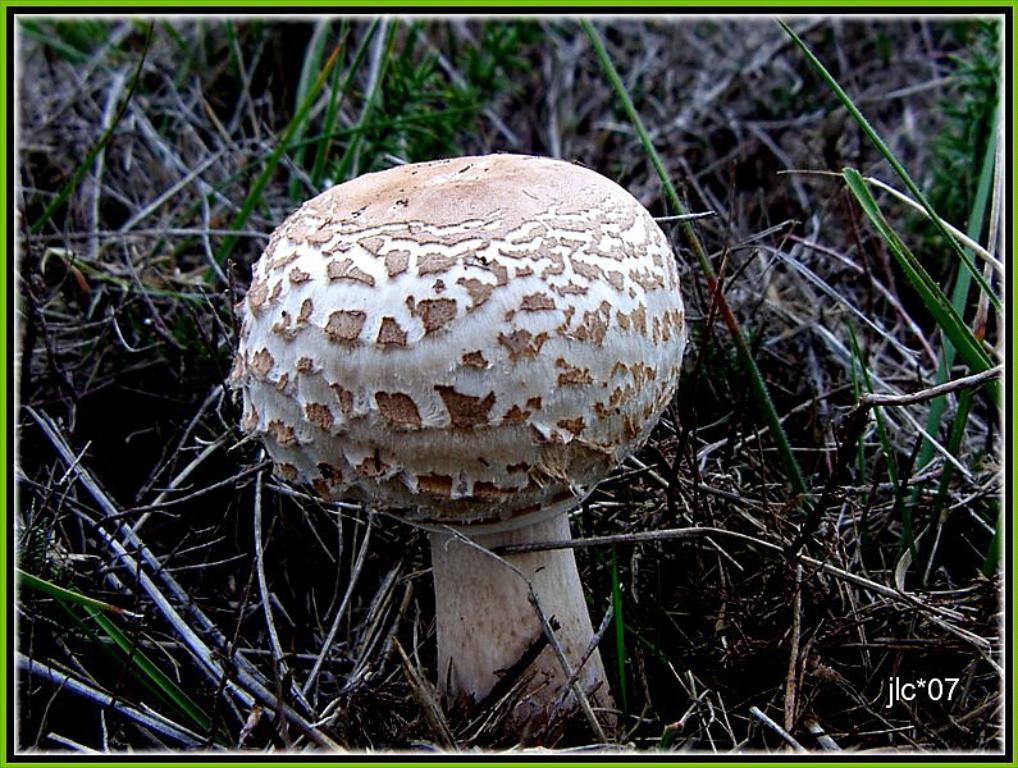Could you give a brief overview of what you see in this image? In this image there is a mushroom. Around it there are green grass and dried grass on the ground. In the bottom right there are numbers and text on the image. There is a border around the image. 